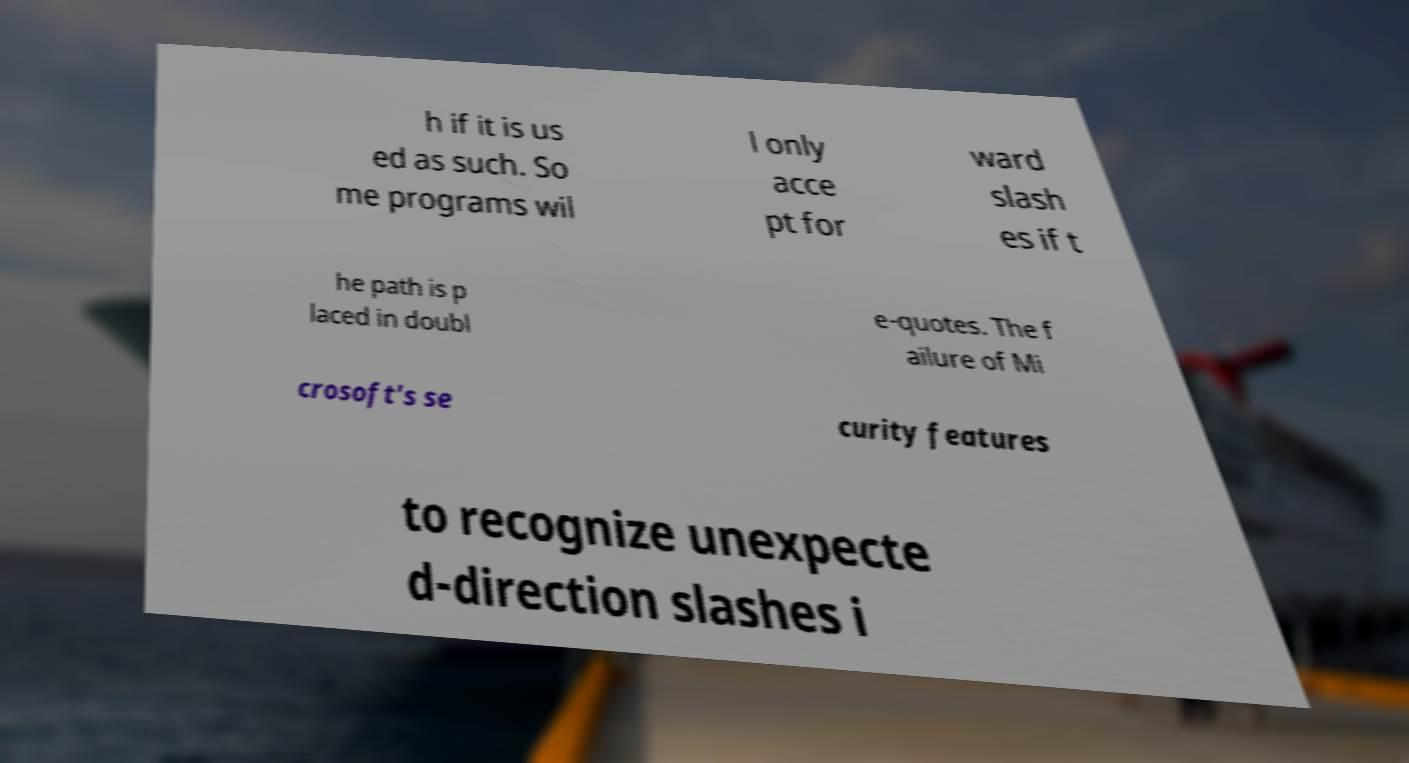Please identify and transcribe the text found in this image. h if it is us ed as such. So me programs wil l only acce pt for ward slash es if t he path is p laced in doubl e-quotes. The f ailure of Mi crosoft's se curity features to recognize unexpecte d-direction slashes i 